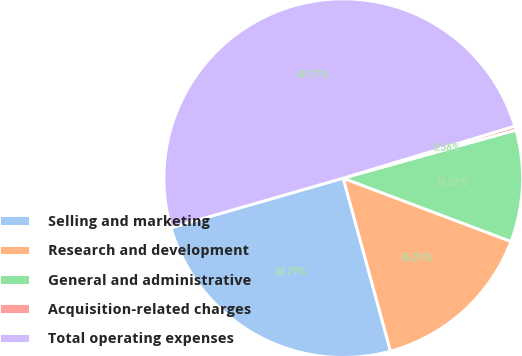Convert chart to OTSL. <chart><loc_0><loc_0><loc_500><loc_500><pie_chart><fcel>Selling and marketing<fcel>Research and development<fcel>General and administrative<fcel>Acquisition-related charges<fcel>Total operating expenses<nl><fcel>24.79%<fcel>15.01%<fcel>10.07%<fcel>0.36%<fcel>49.77%<nl></chart> 